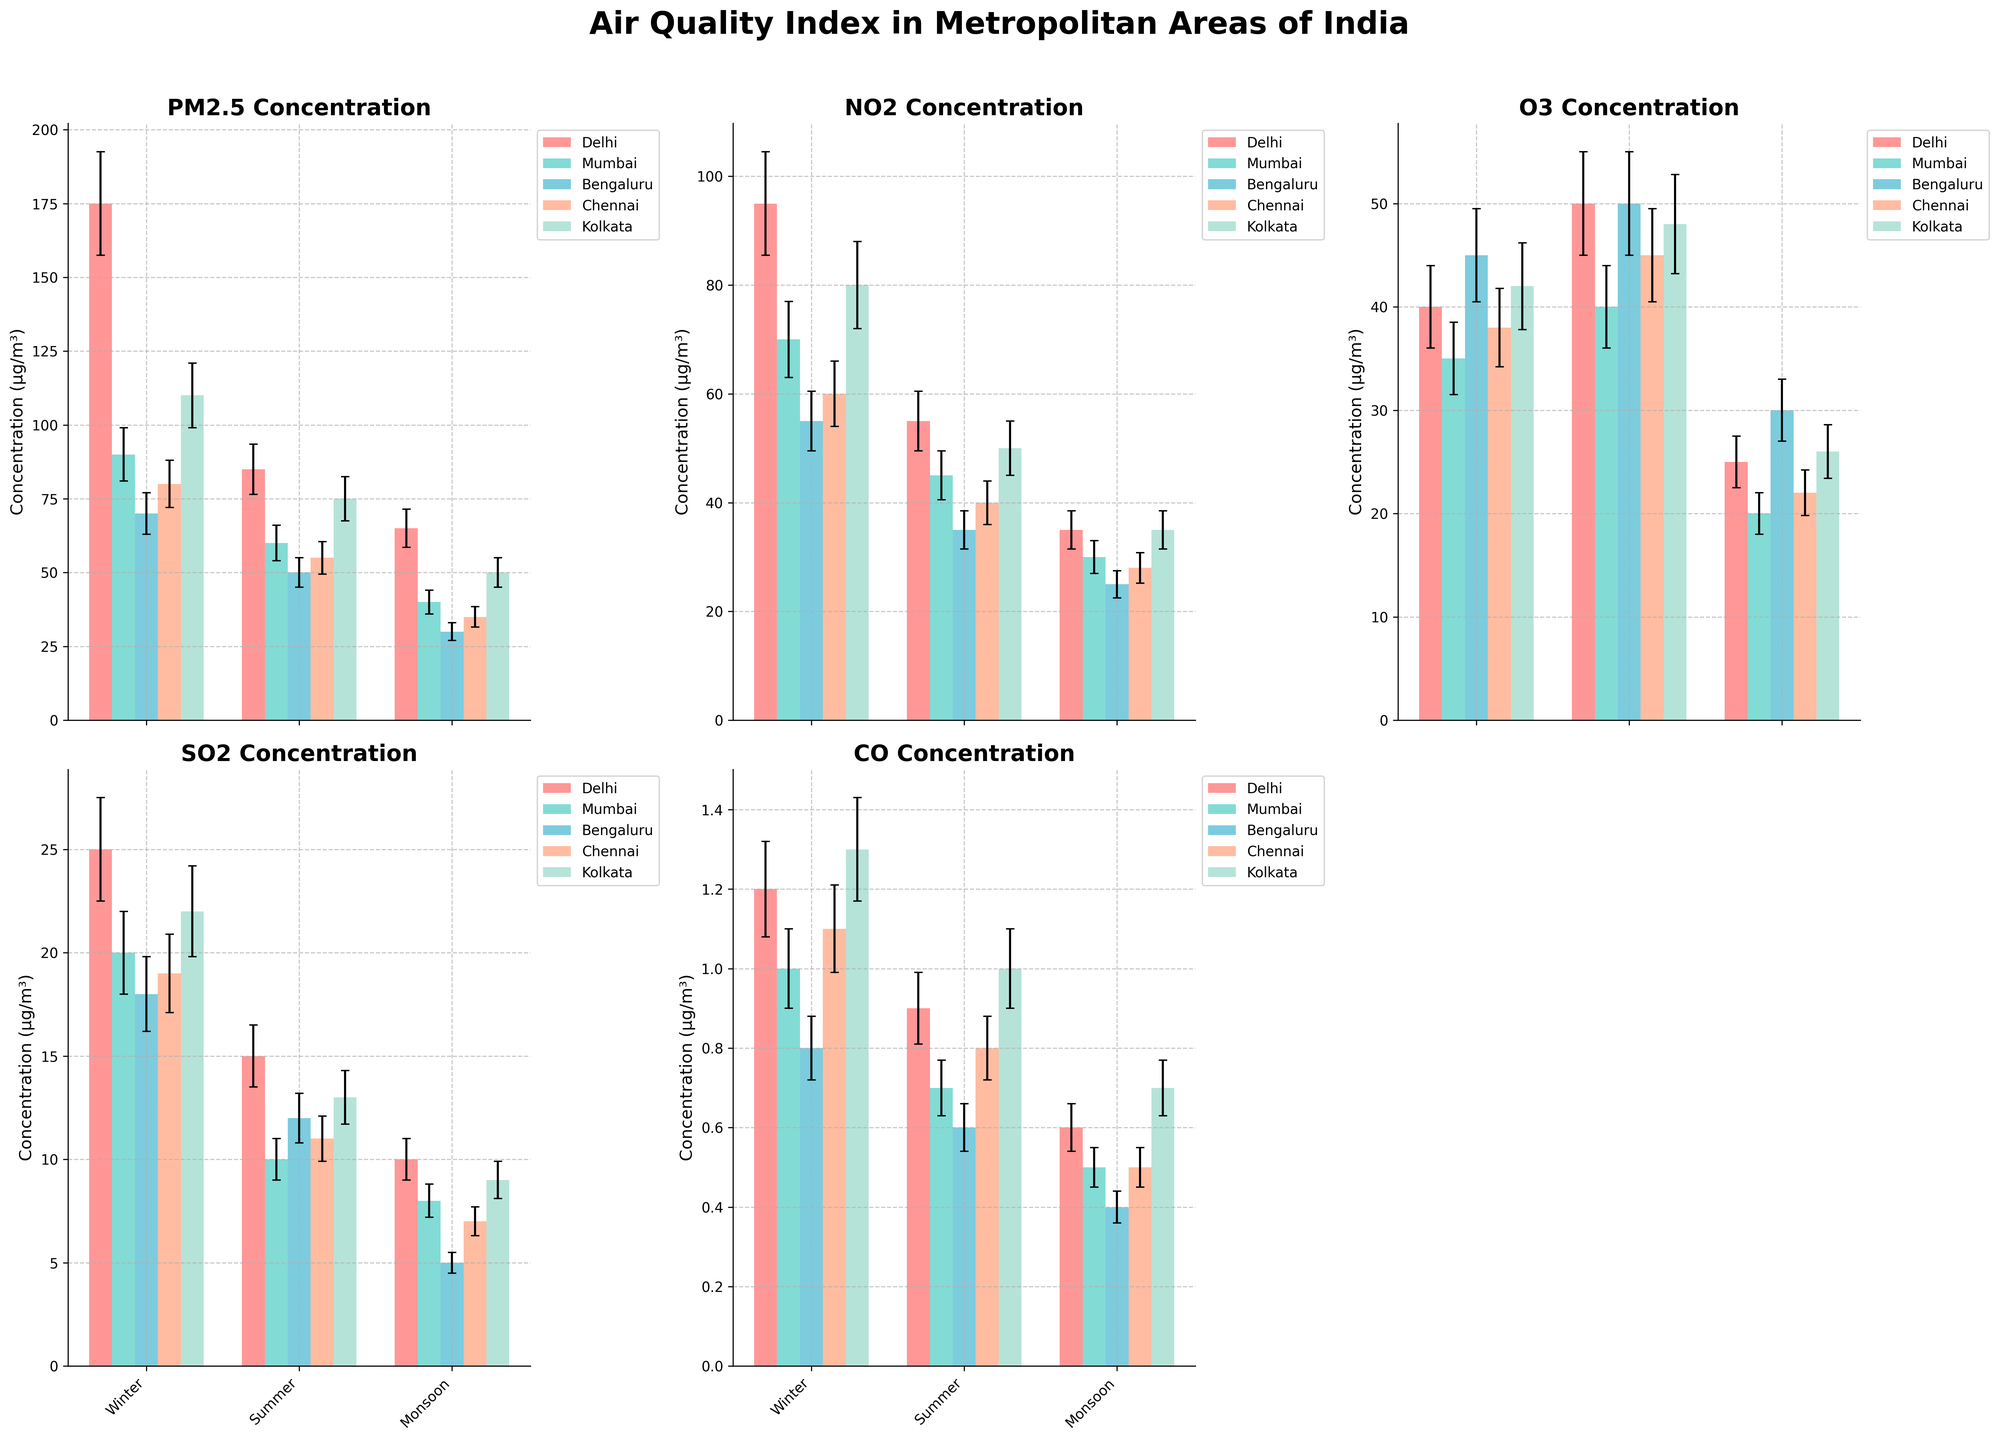What is the title of the figure? The title of the figure is displayed at the top center and provides a summary of the content depicted in the figure.
Answer: Air Quality Index in Metropolitan Areas of India Which city has the highest PM2.5 concentration during winter? To find this, look at the subplot labeled "PM2.5 Concentration" and identify the city with the tallest bar in the winter season.
Answer: Delhi How does the NO2 concentration in Delhi compare between winter and monsoon seasons? Locate the subplot labeled "NO2 Concentration" and compare the heights of the bars for Delhi in the winter and monsoon seasons.
Answer: Higher in winter What is the average SO2 concentration in Mumbai across all seasons? Sum the SO2 concentrations for Mumbai in each season (Winter: 20, Summer: 10, Monsoon: 8) and divide by the number of seasons (3).
Answer: (20 + 10 + 8) / 3 = 12.67 µg/m³ Which pollutant shows an increasing trend from winter to monsoon in Bengaluru? Check each subplot for the bars representing Bengaluru and identify any pollutant concentrations that increase from winter to monsoon.
Answer: None Does Chennai have a higher CO concentration in summer or winter? Observe the subplot labeled "CO Concentration" and compare the bar heights representing Chennai in summer and winter.
Answer: Winter Which city has the lowest O3 concentration in the monsoon season? Look at the subplot labeled "O3 Concentration" and find the city with the shortest bar in the monsoon season.
Answer: Mumbai What is the total concentration of NO2 and O3 in Kolkata during the summer season? Find the NO2 and O3 concentrations for Kolkata in summer (NO2: 50, O3: 48) and sum them up.
Answer: 50 + 48 = 98 µg/m³ Compare the summer CO concentrations of Delhi and Bengaluru. Which city has a higher concentration? Look at the CO subplot and compare the heights of the bars representing Delhi and Bengaluru in summer.
Answer: Delhi Which pollutant has the highest concentration in Mumbai across all seasons? Compare the highest concentrations for each pollutant bar representing Mumbai across all subplots.
Answer: NO2 